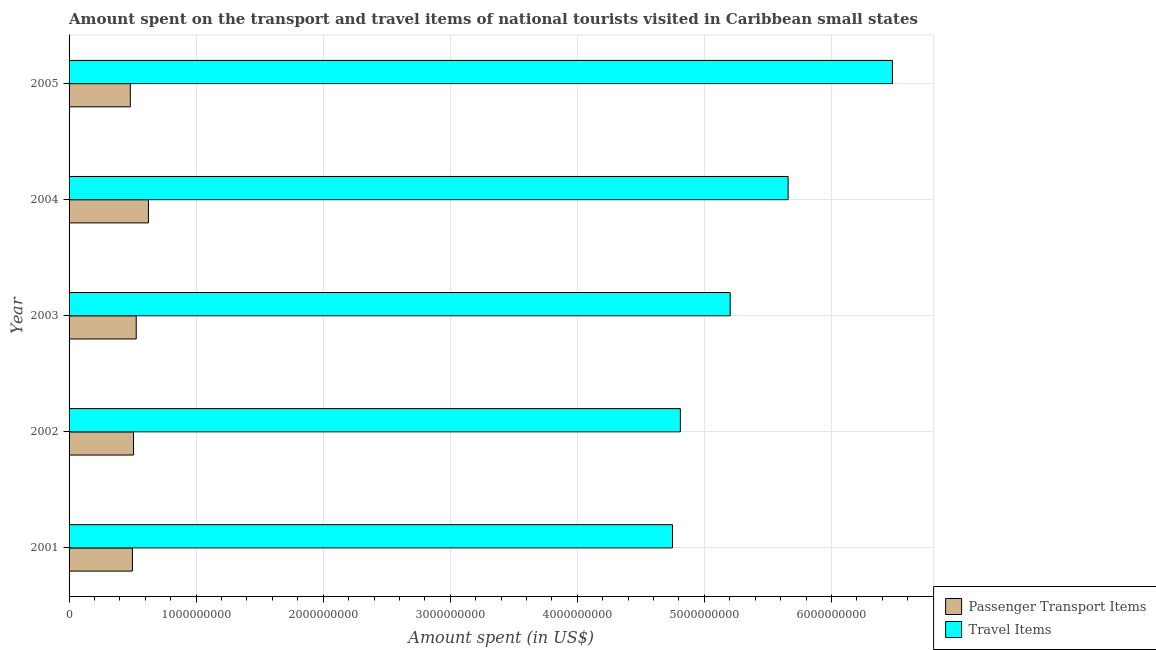Are the number of bars per tick equal to the number of legend labels?
Offer a very short reply. Yes. How many bars are there on the 4th tick from the top?
Keep it short and to the point. 2. What is the label of the 2nd group of bars from the top?
Offer a very short reply. 2004. In how many cases, is the number of bars for a given year not equal to the number of legend labels?
Your answer should be very brief. 0. What is the amount spent on passenger transport items in 2005?
Ensure brevity in your answer.  4.82e+08. Across all years, what is the maximum amount spent on passenger transport items?
Provide a succinct answer. 6.25e+08. Across all years, what is the minimum amount spent on passenger transport items?
Offer a terse response. 4.82e+08. What is the total amount spent on passenger transport items in the graph?
Offer a very short reply. 2.64e+09. What is the difference between the amount spent on passenger transport items in 2003 and that in 2005?
Your answer should be compact. 4.64e+07. What is the difference between the amount spent in travel items in 2004 and the amount spent on passenger transport items in 2005?
Your answer should be compact. 5.18e+09. What is the average amount spent on passenger transport items per year?
Your answer should be compact. 5.28e+08. In the year 2001, what is the difference between the amount spent on passenger transport items and amount spent in travel items?
Your answer should be compact. -4.25e+09. In how many years, is the amount spent on passenger transport items greater than 2400000000 US$?
Provide a succinct answer. 0. What is the ratio of the amount spent in travel items in 2001 to that in 2002?
Make the answer very short. 0.99. Is the amount spent in travel items in 2002 less than that in 2005?
Ensure brevity in your answer.  Yes. Is the difference between the amount spent in travel items in 2001 and 2005 greater than the difference between the amount spent on passenger transport items in 2001 and 2005?
Ensure brevity in your answer.  No. What is the difference between the highest and the second highest amount spent in travel items?
Ensure brevity in your answer.  8.21e+08. What is the difference between the highest and the lowest amount spent on passenger transport items?
Your answer should be compact. 1.42e+08. In how many years, is the amount spent on passenger transport items greater than the average amount spent on passenger transport items taken over all years?
Provide a short and direct response. 2. Is the sum of the amount spent on passenger transport items in 2002 and 2003 greater than the maximum amount spent in travel items across all years?
Your answer should be compact. No. What does the 2nd bar from the top in 2001 represents?
Offer a terse response. Passenger Transport Items. What does the 2nd bar from the bottom in 2002 represents?
Your response must be concise. Travel Items. How many bars are there?
Give a very brief answer. 10. Are all the bars in the graph horizontal?
Provide a short and direct response. Yes. How many years are there in the graph?
Your answer should be very brief. 5. What is the difference between two consecutive major ticks on the X-axis?
Offer a very short reply. 1.00e+09. Are the values on the major ticks of X-axis written in scientific E-notation?
Give a very brief answer. No. Where does the legend appear in the graph?
Your answer should be very brief. Bottom right. How many legend labels are there?
Provide a succinct answer. 2. How are the legend labels stacked?
Your response must be concise. Vertical. What is the title of the graph?
Your answer should be compact. Amount spent on the transport and travel items of national tourists visited in Caribbean small states. Does "Commercial bank branches" appear as one of the legend labels in the graph?
Keep it short and to the point. No. What is the label or title of the X-axis?
Provide a succinct answer. Amount spent (in US$). What is the label or title of the Y-axis?
Your answer should be very brief. Year. What is the Amount spent (in US$) in Passenger Transport Items in 2001?
Keep it short and to the point. 4.98e+08. What is the Amount spent (in US$) of Travel Items in 2001?
Make the answer very short. 4.75e+09. What is the Amount spent (in US$) in Passenger Transport Items in 2002?
Provide a short and direct response. 5.07e+08. What is the Amount spent (in US$) in Travel Items in 2002?
Offer a very short reply. 4.81e+09. What is the Amount spent (in US$) of Passenger Transport Items in 2003?
Ensure brevity in your answer.  5.29e+08. What is the Amount spent (in US$) of Travel Items in 2003?
Provide a succinct answer. 5.20e+09. What is the Amount spent (in US$) of Passenger Transport Items in 2004?
Offer a very short reply. 6.25e+08. What is the Amount spent (in US$) in Travel Items in 2004?
Offer a very short reply. 5.66e+09. What is the Amount spent (in US$) of Passenger Transport Items in 2005?
Your response must be concise. 4.82e+08. What is the Amount spent (in US$) of Travel Items in 2005?
Ensure brevity in your answer.  6.48e+09. Across all years, what is the maximum Amount spent (in US$) of Passenger Transport Items?
Provide a succinct answer. 6.25e+08. Across all years, what is the maximum Amount spent (in US$) in Travel Items?
Ensure brevity in your answer.  6.48e+09. Across all years, what is the minimum Amount spent (in US$) in Passenger Transport Items?
Give a very brief answer. 4.82e+08. Across all years, what is the minimum Amount spent (in US$) in Travel Items?
Your answer should be compact. 4.75e+09. What is the total Amount spent (in US$) of Passenger Transport Items in the graph?
Provide a short and direct response. 2.64e+09. What is the total Amount spent (in US$) in Travel Items in the graph?
Offer a terse response. 2.69e+1. What is the difference between the Amount spent (in US$) in Passenger Transport Items in 2001 and that in 2002?
Make the answer very short. -8.59e+06. What is the difference between the Amount spent (in US$) of Travel Items in 2001 and that in 2002?
Keep it short and to the point. -6.20e+07. What is the difference between the Amount spent (in US$) in Passenger Transport Items in 2001 and that in 2003?
Make the answer very short. -3.01e+07. What is the difference between the Amount spent (in US$) in Travel Items in 2001 and that in 2003?
Give a very brief answer. -4.54e+08. What is the difference between the Amount spent (in US$) in Passenger Transport Items in 2001 and that in 2004?
Keep it short and to the point. -1.26e+08. What is the difference between the Amount spent (in US$) of Travel Items in 2001 and that in 2004?
Offer a very short reply. -9.10e+08. What is the difference between the Amount spent (in US$) in Passenger Transport Items in 2001 and that in 2005?
Provide a succinct answer. 1.63e+07. What is the difference between the Amount spent (in US$) of Travel Items in 2001 and that in 2005?
Offer a very short reply. -1.73e+09. What is the difference between the Amount spent (in US$) of Passenger Transport Items in 2002 and that in 2003?
Give a very brief answer. -2.15e+07. What is the difference between the Amount spent (in US$) in Travel Items in 2002 and that in 2003?
Offer a very short reply. -3.92e+08. What is the difference between the Amount spent (in US$) of Passenger Transport Items in 2002 and that in 2004?
Keep it short and to the point. -1.17e+08. What is the difference between the Amount spent (in US$) of Travel Items in 2002 and that in 2004?
Keep it short and to the point. -8.48e+08. What is the difference between the Amount spent (in US$) in Passenger Transport Items in 2002 and that in 2005?
Your answer should be compact. 2.49e+07. What is the difference between the Amount spent (in US$) in Travel Items in 2002 and that in 2005?
Offer a terse response. -1.67e+09. What is the difference between the Amount spent (in US$) of Passenger Transport Items in 2003 and that in 2004?
Provide a short and direct response. -9.60e+07. What is the difference between the Amount spent (in US$) of Travel Items in 2003 and that in 2004?
Offer a very short reply. -4.56e+08. What is the difference between the Amount spent (in US$) in Passenger Transport Items in 2003 and that in 2005?
Provide a succinct answer. 4.64e+07. What is the difference between the Amount spent (in US$) in Travel Items in 2003 and that in 2005?
Give a very brief answer. -1.28e+09. What is the difference between the Amount spent (in US$) of Passenger Transport Items in 2004 and that in 2005?
Your answer should be compact. 1.42e+08. What is the difference between the Amount spent (in US$) of Travel Items in 2004 and that in 2005?
Your response must be concise. -8.21e+08. What is the difference between the Amount spent (in US$) of Passenger Transport Items in 2001 and the Amount spent (in US$) of Travel Items in 2002?
Offer a terse response. -4.31e+09. What is the difference between the Amount spent (in US$) of Passenger Transport Items in 2001 and the Amount spent (in US$) of Travel Items in 2003?
Your answer should be compact. -4.70e+09. What is the difference between the Amount spent (in US$) in Passenger Transport Items in 2001 and the Amount spent (in US$) in Travel Items in 2004?
Your response must be concise. -5.16e+09. What is the difference between the Amount spent (in US$) of Passenger Transport Items in 2001 and the Amount spent (in US$) of Travel Items in 2005?
Your answer should be compact. -5.98e+09. What is the difference between the Amount spent (in US$) in Passenger Transport Items in 2002 and the Amount spent (in US$) in Travel Items in 2003?
Provide a succinct answer. -4.70e+09. What is the difference between the Amount spent (in US$) of Passenger Transport Items in 2002 and the Amount spent (in US$) of Travel Items in 2004?
Make the answer very short. -5.15e+09. What is the difference between the Amount spent (in US$) of Passenger Transport Items in 2002 and the Amount spent (in US$) of Travel Items in 2005?
Your answer should be very brief. -5.97e+09. What is the difference between the Amount spent (in US$) in Passenger Transport Items in 2003 and the Amount spent (in US$) in Travel Items in 2004?
Provide a succinct answer. -5.13e+09. What is the difference between the Amount spent (in US$) in Passenger Transport Items in 2003 and the Amount spent (in US$) in Travel Items in 2005?
Your answer should be very brief. -5.95e+09. What is the difference between the Amount spent (in US$) in Passenger Transport Items in 2004 and the Amount spent (in US$) in Travel Items in 2005?
Make the answer very short. -5.86e+09. What is the average Amount spent (in US$) of Passenger Transport Items per year?
Your response must be concise. 5.28e+08. What is the average Amount spent (in US$) in Travel Items per year?
Keep it short and to the point. 5.38e+09. In the year 2001, what is the difference between the Amount spent (in US$) of Passenger Transport Items and Amount spent (in US$) of Travel Items?
Offer a terse response. -4.25e+09. In the year 2002, what is the difference between the Amount spent (in US$) in Passenger Transport Items and Amount spent (in US$) in Travel Items?
Your answer should be very brief. -4.30e+09. In the year 2003, what is the difference between the Amount spent (in US$) in Passenger Transport Items and Amount spent (in US$) in Travel Items?
Offer a terse response. -4.67e+09. In the year 2004, what is the difference between the Amount spent (in US$) of Passenger Transport Items and Amount spent (in US$) of Travel Items?
Offer a very short reply. -5.03e+09. In the year 2005, what is the difference between the Amount spent (in US$) in Passenger Transport Items and Amount spent (in US$) in Travel Items?
Make the answer very short. -6.00e+09. What is the ratio of the Amount spent (in US$) of Passenger Transport Items in 2001 to that in 2002?
Provide a short and direct response. 0.98. What is the ratio of the Amount spent (in US$) in Travel Items in 2001 to that in 2002?
Your answer should be compact. 0.99. What is the ratio of the Amount spent (in US$) of Passenger Transport Items in 2001 to that in 2003?
Ensure brevity in your answer.  0.94. What is the ratio of the Amount spent (in US$) in Travel Items in 2001 to that in 2003?
Your answer should be very brief. 0.91. What is the ratio of the Amount spent (in US$) of Passenger Transport Items in 2001 to that in 2004?
Provide a succinct answer. 0.8. What is the ratio of the Amount spent (in US$) in Travel Items in 2001 to that in 2004?
Give a very brief answer. 0.84. What is the ratio of the Amount spent (in US$) of Passenger Transport Items in 2001 to that in 2005?
Give a very brief answer. 1.03. What is the ratio of the Amount spent (in US$) of Travel Items in 2001 to that in 2005?
Give a very brief answer. 0.73. What is the ratio of the Amount spent (in US$) of Passenger Transport Items in 2002 to that in 2003?
Make the answer very short. 0.96. What is the ratio of the Amount spent (in US$) in Travel Items in 2002 to that in 2003?
Give a very brief answer. 0.92. What is the ratio of the Amount spent (in US$) in Passenger Transport Items in 2002 to that in 2004?
Your response must be concise. 0.81. What is the ratio of the Amount spent (in US$) of Travel Items in 2002 to that in 2004?
Your answer should be very brief. 0.85. What is the ratio of the Amount spent (in US$) of Passenger Transport Items in 2002 to that in 2005?
Your answer should be compact. 1.05. What is the ratio of the Amount spent (in US$) of Travel Items in 2002 to that in 2005?
Provide a short and direct response. 0.74. What is the ratio of the Amount spent (in US$) of Passenger Transport Items in 2003 to that in 2004?
Provide a succinct answer. 0.85. What is the ratio of the Amount spent (in US$) of Travel Items in 2003 to that in 2004?
Offer a very short reply. 0.92. What is the ratio of the Amount spent (in US$) of Passenger Transport Items in 2003 to that in 2005?
Your answer should be very brief. 1.1. What is the ratio of the Amount spent (in US$) of Travel Items in 2003 to that in 2005?
Provide a short and direct response. 0.8. What is the ratio of the Amount spent (in US$) of Passenger Transport Items in 2004 to that in 2005?
Offer a very short reply. 1.3. What is the ratio of the Amount spent (in US$) of Travel Items in 2004 to that in 2005?
Your answer should be compact. 0.87. What is the difference between the highest and the second highest Amount spent (in US$) of Passenger Transport Items?
Ensure brevity in your answer.  9.60e+07. What is the difference between the highest and the second highest Amount spent (in US$) in Travel Items?
Your answer should be very brief. 8.21e+08. What is the difference between the highest and the lowest Amount spent (in US$) of Passenger Transport Items?
Ensure brevity in your answer.  1.42e+08. What is the difference between the highest and the lowest Amount spent (in US$) in Travel Items?
Give a very brief answer. 1.73e+09. 